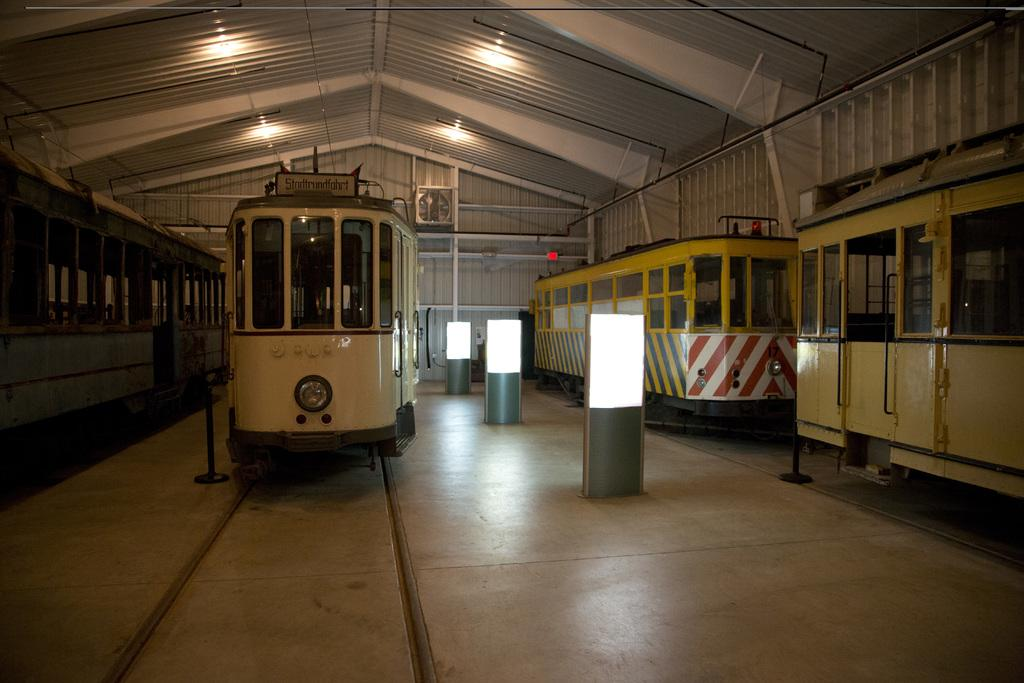What type of vehicles can be seen on the track in the image? There are trains on the track in the image. What other objects are present on the floor in the image? There are poles with lights on the floor in the image. What is visible above the trains in the image? There is a roof with ceiling lights visible in the image. What type of cream can be seen dripping from the ceiling lights in the image? There is no cream present in the image, nor is there any dripping substance from the ceiling lights. 